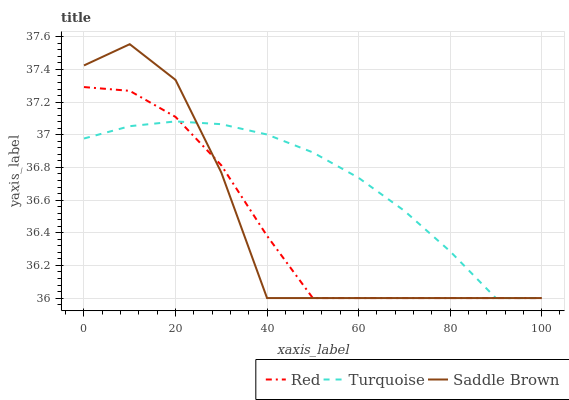Does Red have the minimum area under the curve?
Answer yes or no. Yes. Does Turquoise have the maximum area under the curve?
Answer yes or no. Yes. Does Saddle Brown have the minimum area under the curve?
Answer yes or no. No. Does Saddle Brown have the maximum area under the curve?
Answer yes or no. No. Is Turquoise the smoothest?
Answer yes or no. Yes. Is Saddle Brown the roughest?
Answer yes or no. Yes. Is Red the smoothest?
Answer yes or no. No. Is Red the roughest?
Answer yes or no. No. Does Turquoise have the lowest value?
Answer yes or no. Yes. Does Saddle Brown have the highest value?
Answer yes or no. Yes. Does Red have the highest value?
Answer yes or no. No. Does Red intersect Turquoise?
Answer yes or no. Yes. Is Red less than Turquoise?
Answer yes or no. No. Is Red greater than Turquoise?
Answer yes or no. No. 